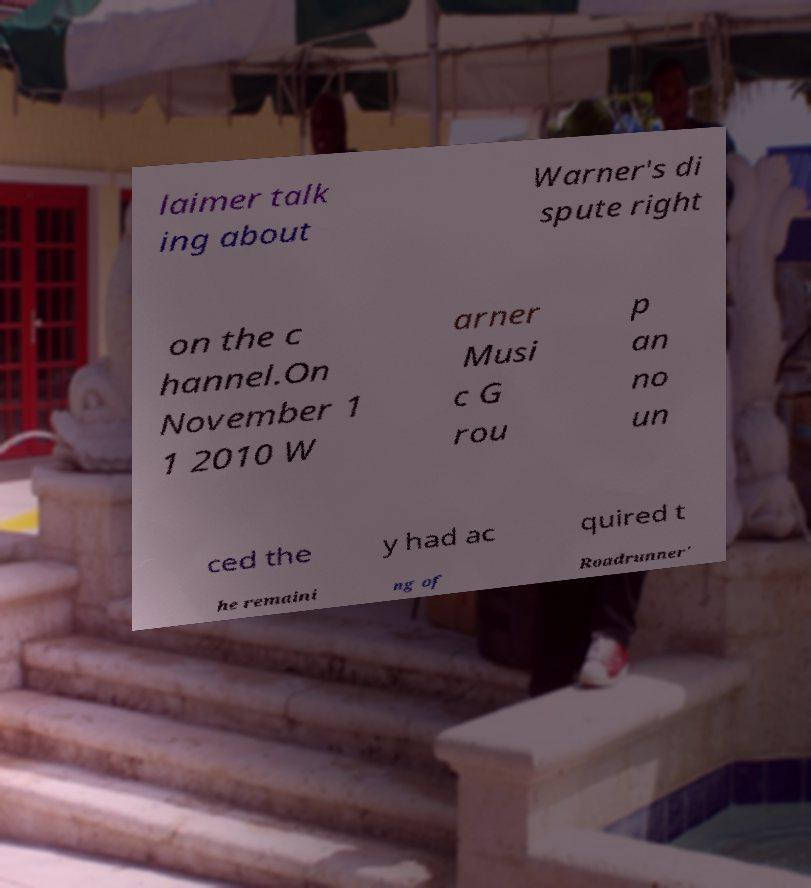Can you read and provide the text displayed in the image?This photo seems to have some interesting text. Can you extract and type it out for me? laimer talk ing about Warner's di spute right on the c hannel.On November 1 1 2010 W arner Musi c G rou p an no un ced the y had ac quired t he remaini ng of Roadrunner' 